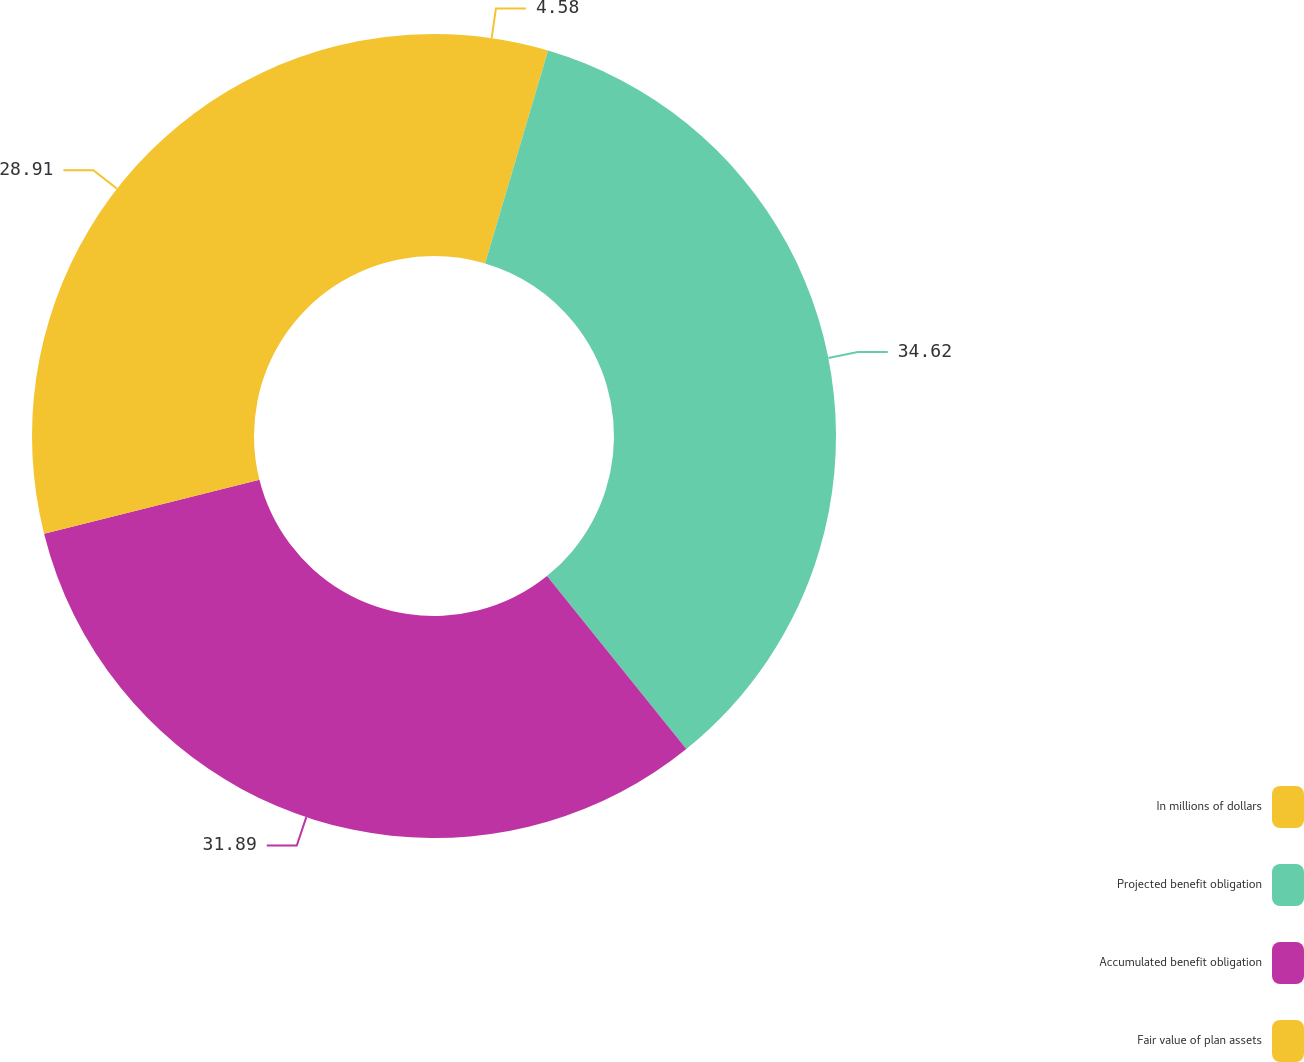<chart> <loc_0><loc_0><loc_500><loc_500><pie_chart><fcel>In millions of dollars<fcel>Projected benefit obligation<fcel>Accumulated benefit obligation<fcel>Fair value of plan assets<nl><fcel>4.58%<fcel>34.62%<fcel>31.89%<fcel>28.91%<nl></chart> 